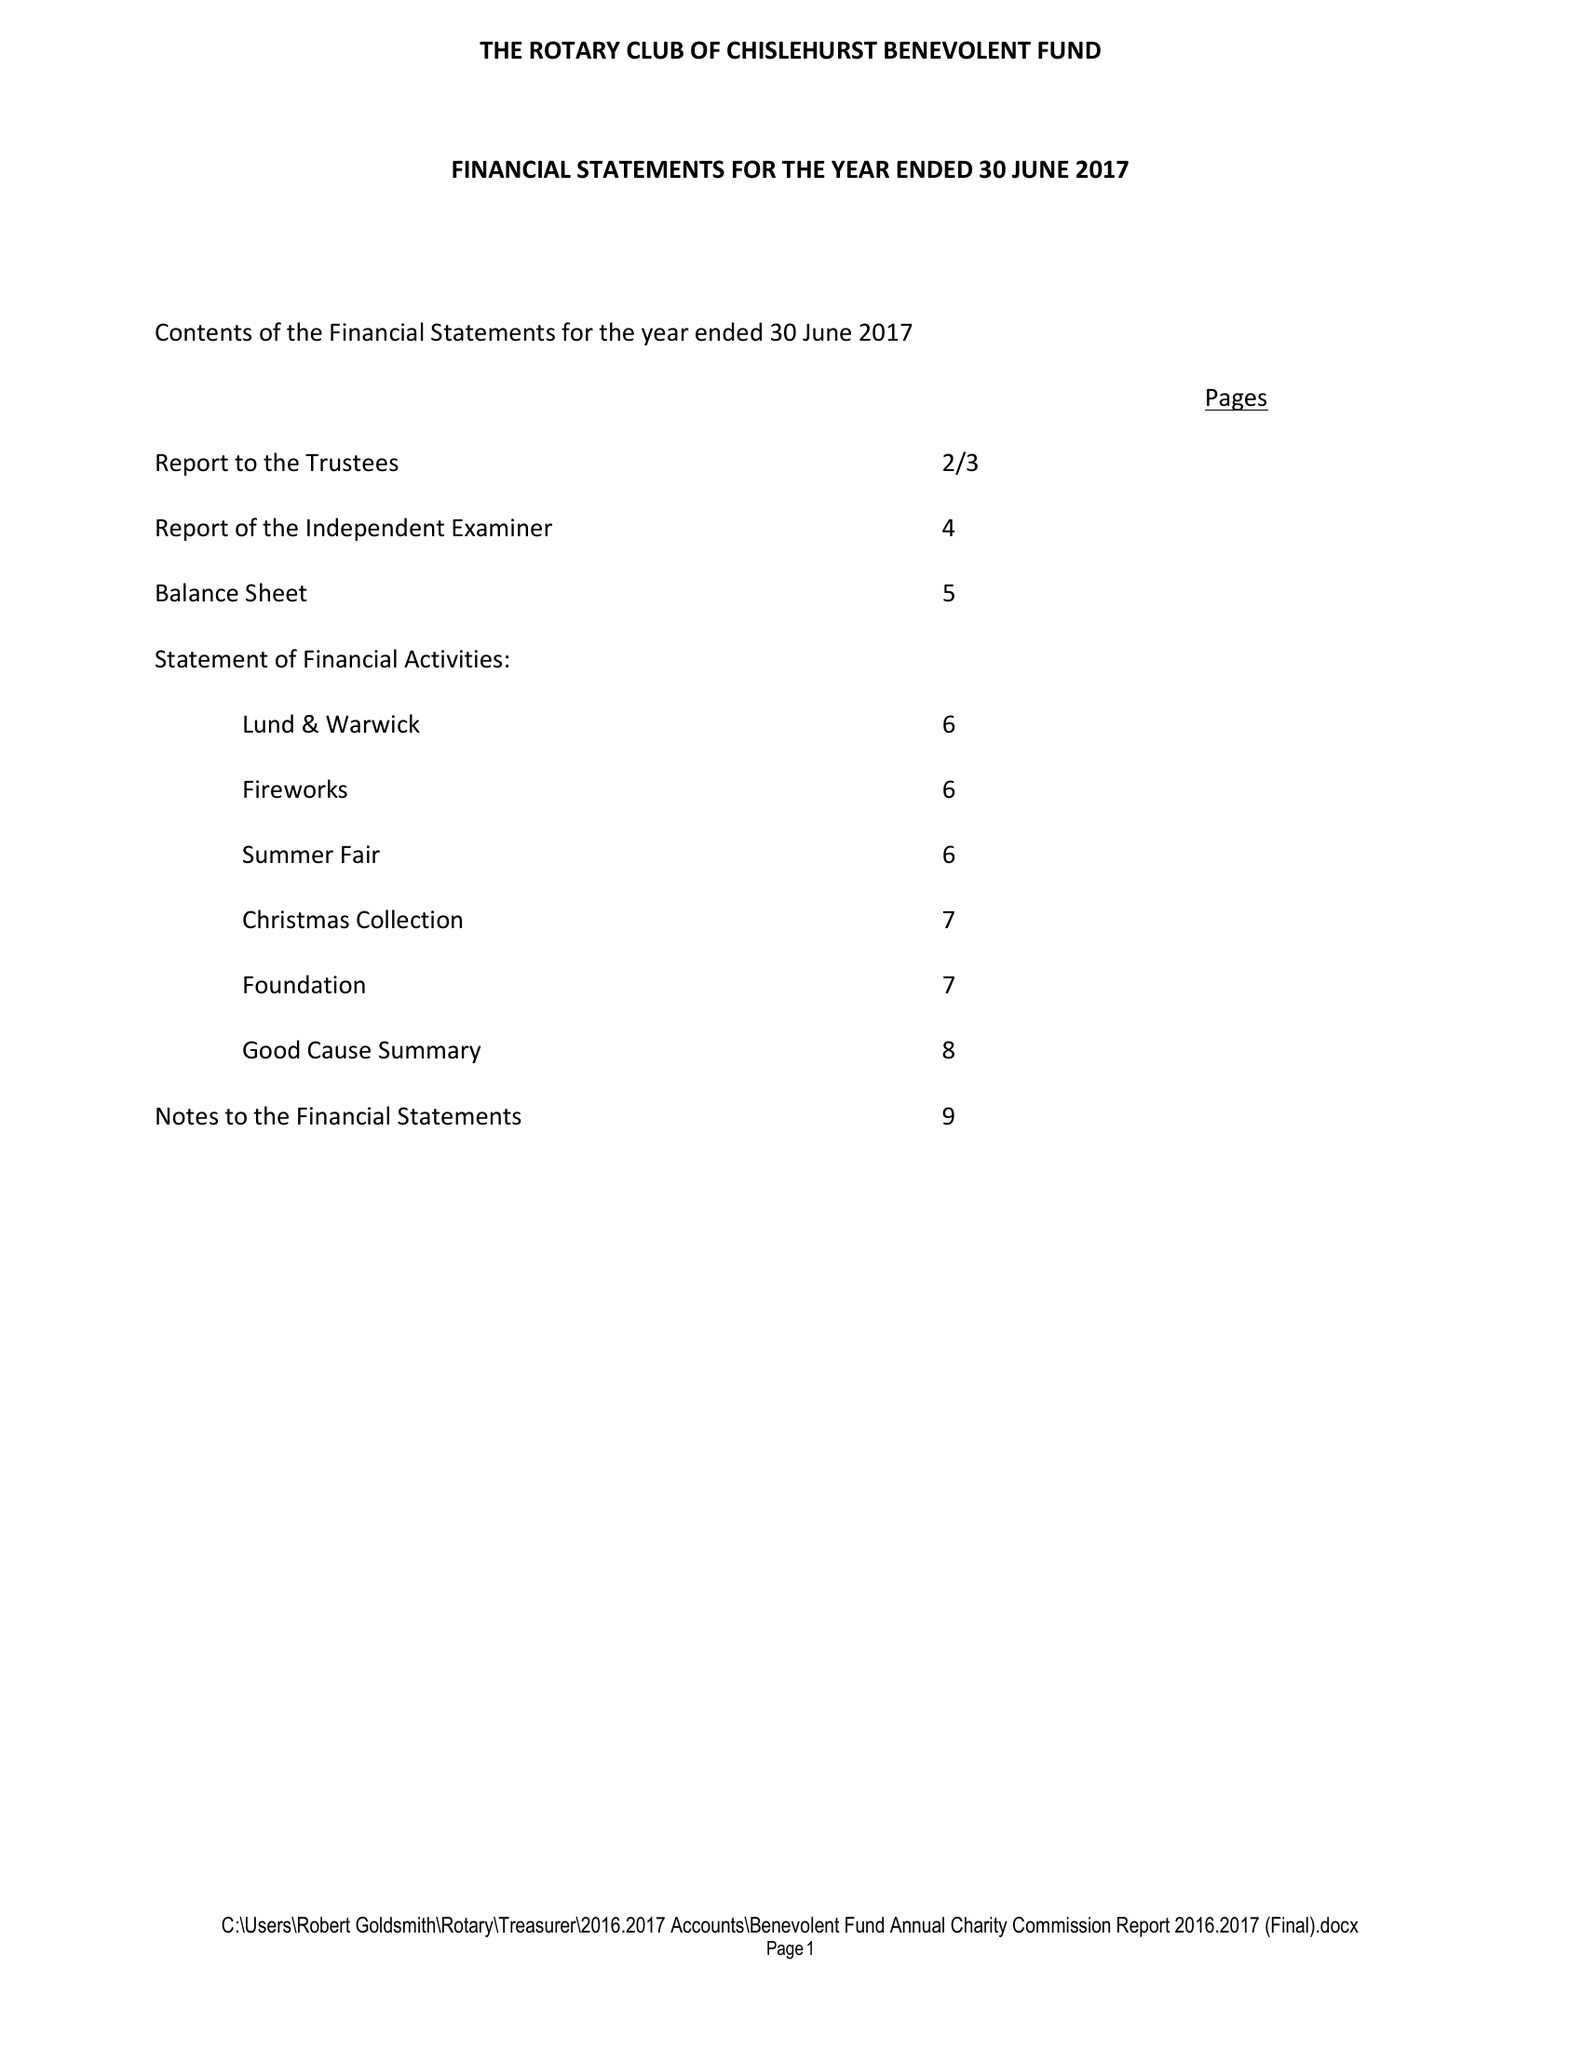What is the value for the charity_number?
Answer the question using a single word or phrase. 257747 